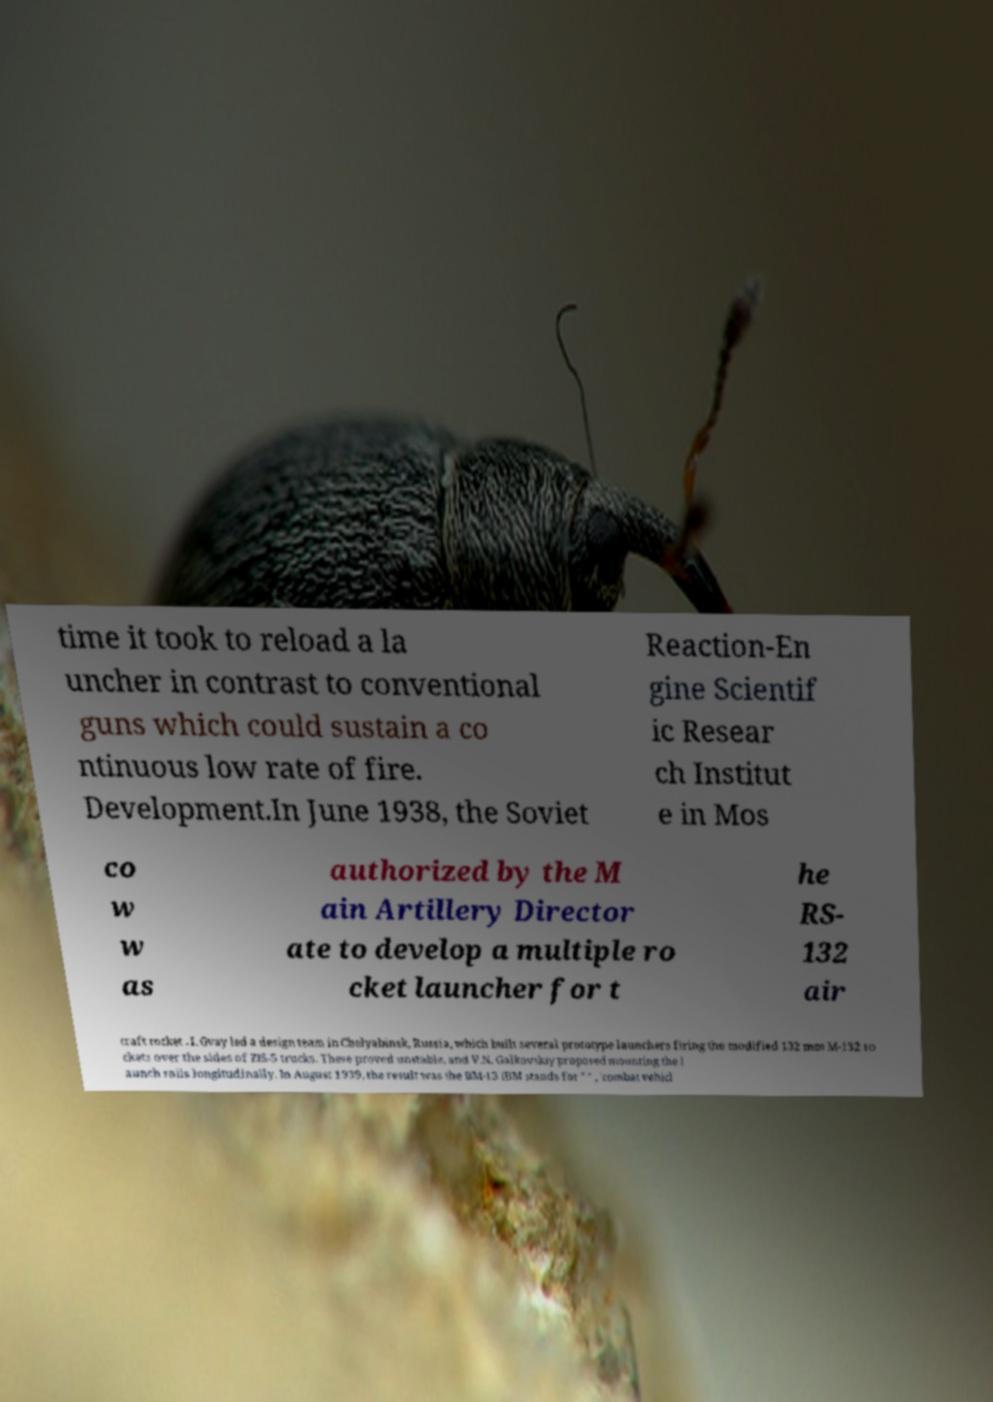Could you extract and type out the text from this image? time it took to reload a la uncher in contrast to conventional guns which could sustain a co ntinuous low rate of fire. Development.In June 1938, the Soviet Reaction-En gine Scientif ic Resear ch Institut e in Mos co w w as authorized by the M ain Artillery Director ate to develop a multiple ro cket launcher for t he RS- 132 air craft rocket . I. Gvay led a design team in Chelyabinsk, Russia, which built several prototype launchers firing the modified 132 mm M-132 ro ckets over the sides of ZIS-5 trucks. These proved unstable, and V.N. Galkovskiy proposed mounting the l aunch rails longitudinally. In August 1939, the result was the BM-13 (BM stands for " " , 'combat vehicl 